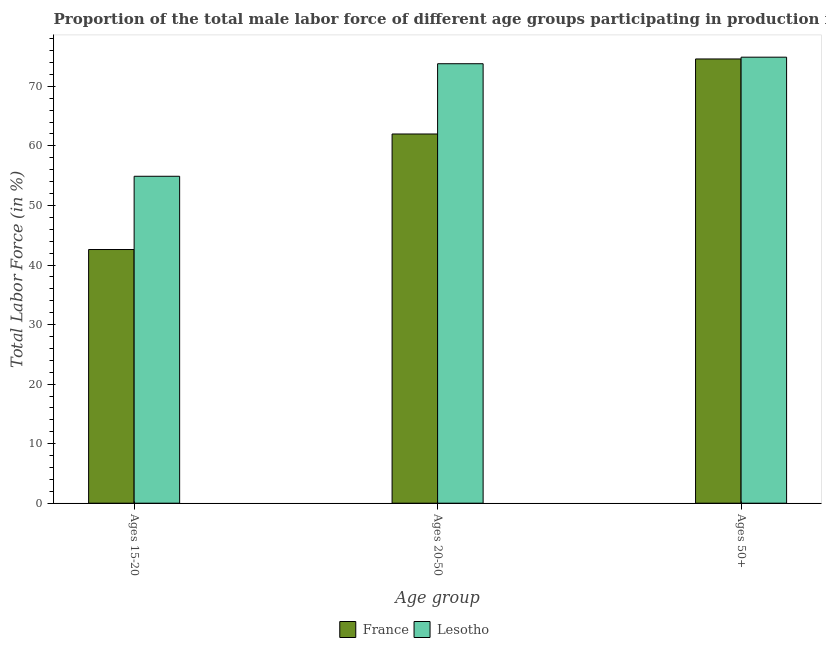How many different coloured bars are there?
Keep it short and to the point. 2. How many bars are there on the 2nd tick from the left?
Ensure brevity in your answer.  2. How many bars are there on the 3rd tick from the right?
Your answer should be very brief. 2. What is the label of the 3rd group of bars from the left?
Make the answer very short. Ages 50+. What is the percentage of male labor force within the age group 15-20 in France?
Keep it short and to the point. 42.6. Across all countries, what is the maximum percentage of male labor force above age 50?
Keep it short and to the point. 74.9. Across all countries, what is the minimum percentage of male labor force above age 50?
Give a very brief answer. 74.6. In which country was the percentage of male labor force above age 50 maximum?
Your answer should be very brief. Lesotho. In which country was the percentage of male labor force within the age group 15-20 minimum?
Offer a very short reply. France. What is the total percentage of male labor force within the age group 20-50 in the graph?
Provide a succinct answer. 135.8. What is the difference between the percentage of male labor force within the age group 20-50 in France and that in Lesotho?
Your answer should be very brief. -11.8. What is the difference between the percentage of male labor force above age 50 in Lesotho and the percentage of male labor force within the age group 20-50 in France?
Make the answer very short. 12.9. What is the average percentage of male labor force above age 50 per country?
Keep it short and to the point. 74.75. What is the difference between the percentage of male labor force within the age group 20-50 and percentage of male labor force above age 50 in Lesotho?
Your response must be concise. -1.1. In how many countries, is the percentage of male labor force within the age group 15-20 greater than 14 %?
Offer a terse response. 2. What is the ratio of the percentage of male labor force within the age group 15-20 in Lesotho to that in France?
Your response must be concise. 1.29. Is the percentage of male labor force within the age group 20-50 in France less than that in Lesotho?
Your answer should be compact. Yes. Is the difference between the percentage of male labor force within the age group 20-50 in France and Lesotho greater than the difference between the percentage of male labor force above age 50 in France and Lesotho?
Your response must be concise. No. What is the difference between the highest and the second highest percentage of male labor force within the age group 20-50?
Your response must be concise. 11.8. What is the difference between the highest and the lowest percentage of male labor force within the age group 20-50?
Ensure brevity in your answer.  11.8. Is the sum of the percentage of male labor force above age 50 in France and Lesotho greater than the maximum percentage of male labor force within the age group 20-50 across all countries?
Offer a terse response. Yes. Is it the case that in every country, the sum of the percentage of male labor force within the age group 15-20 and percentage of male labor force within the age group 20-50 is greater than the percentage of male labor force above age 50?
Give a very brief answer. Yes. How many bars are there?
Your response must be concise. 6. Does the graph contain any zero values?
Your response must be concise. No. Where does the legend appear in the graph?
Ensure brevity in your answer.  Bottom center. What is the title of the graph?
Provide a short and direct response. Proportion of the total male labor force of different age groups participating in production in 2007. What is the label or title of the X-axis?
Offer a very short reply. Age group. What is the Total Labor Force (in %) in France in Ages 15-20?
Provide a succinct answer. 42.6. What is the Total Labor Force (in %) in Lesotho in Ages 15-20?
Offer a very short reply. 54.9. What is the Total Labor Force (in %) of France in Ages 20-50?
Your answer should be very brief. 62. What is the Total Labor Force (in %) of Lesotho in Ages 20-50?
Your response must be concise. 73.8. What is the Total Labor Force (in %) of France in Ages 50+?
Your answer should be compact. 74.6. What is the Total Labor Force (in %) of Lesotho in Ages 50+?
Keep it short and to the point. 74.9. Across all Age group, what is the maximum Total Labor Force (in %) of France?
Your response must be concise. 74.6. Across all Age group, what is the maximum Total Labor Force (in %) of Lesotho?
Your response must be concise. 74.9. Across all Age group, what is the minimum Total Labor Force (in %) in France?
Provide a succinct answer. 42.6. Across all Age group, what is the minimum Total Labor Force (in %) in Lesotho?
Make the answer very short. 54.9. What is the total Total Labor Force (in %) in France in the graph?
Your answer should be very brief. 179.2. What is the total Total Labor Force (in %) in Lesotho in the graph?
Keep it short and to the point. 203.6. What is the difference between the Total Labor Force (in %) of France in Ages 15-20 and that in Ages 20-50?
Offer a terse response. -19.4. What is the difference between the Total Labor Force (in %) in Lesotho in Ages 15-20 and that in Ages 20-50?
Provide a short and direct response. -18.9. What is the difference between the Total Labor Force (in %) of France in Ages 15-20 and that in Ages 50+?
Keep it short and to the point. -32. What is the difference between the Total Labor Force (in %) of Lesotho in Ages 15-20 and that in Ages 50+?
Give a very brief answer. -20. What is the difference between the Total Labor Force (in %) in France in Ages 15-20 and the Total Labor Force (in %) in Lesotho in Ages 20-50?
Your answer should be compact. -31.2. What is the difference between the Total Labor Force (in %) of France in Ages 15-20 and the Total Labor Force (in %) of Lesotho in Ages 50+?
Give a very brief answer. -32.3. What is the difference between the Total Labor Force (in %) in France in Ages 20-50 and the Total Labor Force (in %) in Lesotho in Ages 50+?
Your answer should be compact. -12.9. What is the average Total Labor Force (in %) of France per Age group?
Ensure brevity in your answer.  59.73. What is the average Total Labor Force (in %) in Lesotho per Age group?
Provide a short and direct response. 67.87. What is the difference between the Total Labor Force (in %) of France and Total Labor Force (in %) of Lesotho in Ages 15-20?
Offer a very short reply. -12.3. What is the ratio of the Total Labor Force (in %) of France in Ages 15-20 to that in Ages 20-50?
Offer a terse response. 0.69. What is the ratio of the Total Labor Force (in %) of Lesotho in Ages 15-20 to that in Ages 20-50?
Make the answer very short. 0.74. What is the ratio of the Total Labor Force (in %) of France in Ages 15-20 to that in Ages 50+?
Provide a succinct answer. 0.57. What is the ratio of the Total Labor Force (in %) of Lesotho in Ages 15-20 to that in Ages 50+?
Offer a terse response. 0.73. What is the ratio of the Total Labor Force (in %) of France in Ages 20-50 to that in Ages 50+?
Offer a terse response. 0.83. What is the ratio of the Total Labor Force (in %) in Lesotho in Ages 20-50 to that in Ages 50+?
Offer a very short reply. 0.99. What is the difference between the highest and the second highest Total Labor Force (in %) in France?
Make the answer very short. 12.6. What is the difference between the highest and the second highest Total Labor Force (in %) in Lesotho?
Keep it short and to the point. 1.1. What is the difference between the highest and the lowest Total Labor Force (in %) in Lesotho?
Provide a short and direct response. 20. 